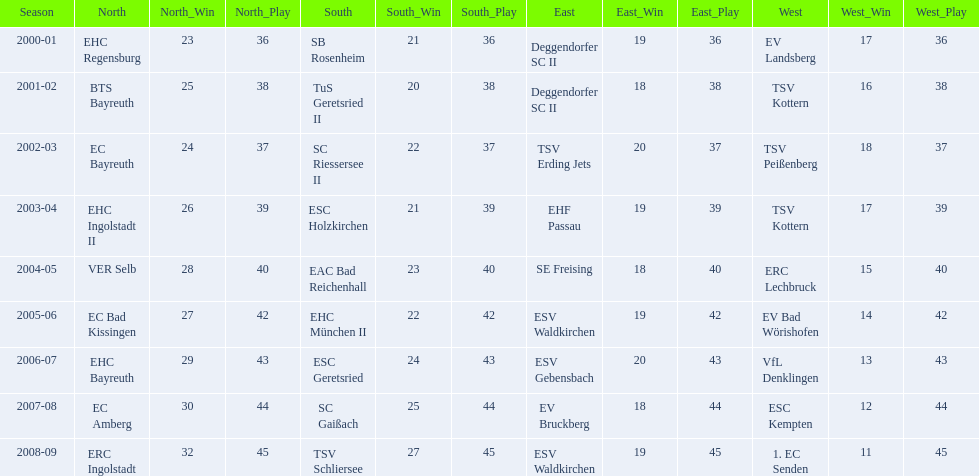Which teams have won in the bavarian ice hockey leagues between 2000 and 2009? EHC Regensburg, SB Rosenheim, Deggendorfer SC II, EV Landsberg, BTS Bayreuth, TuS Geretsried II, TSV Kottern, EC Bayreuth, SC Riessersee II, TSV Erding Jets, TSV Peißenberg, EHC Ingolstadt II, ESC Holzkirchen, EHF Passau, TSV Kottern, VER Selb, EAC Bad Reichenhall, SE Freising, ERC Lechbruck, EC Bad Kissingen, EHC München II, ESV Waldkirchen, EV Bad Wörishofen, EHC Bayreuth, ESC Geretsried, ESV Gebensbach, VfL Denklingen, EC Amberg, SC Gaißach, EV Bruckberg, ESC Kempten, ERC Ingolstadt, TSV Schliersee, ESV Waldkirchen, 1. EC Senden. Which of these winning teams have won the north? EHC Regensburg, BTS Bayreuth, EC Bayreuth, EHC Ingolstadt II, VER Selb, EC Bad Kissingen, EHC Bayreuth, EC Amberg, ERC Ingolstadt. Which of the teams that won the north won in the 2000/2001 season? EHC Regensburg. 